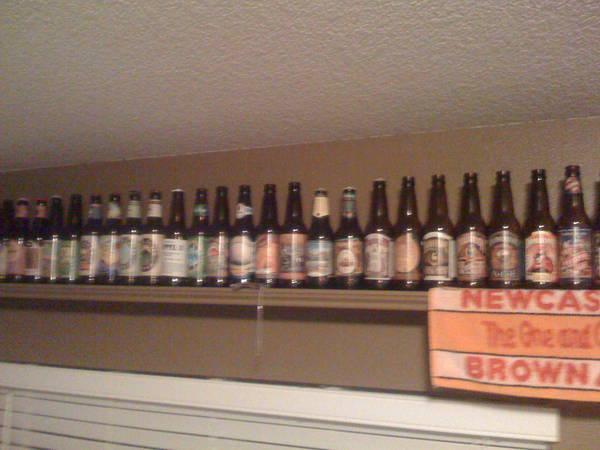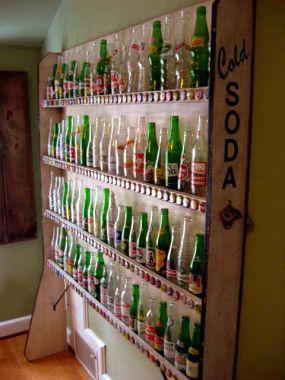The first image is the image on the left, the second image is the image on the right. Considering the images on both sides, is "The bottles in one of the images do not have caps." valid? Answer yes or no. Yes. 